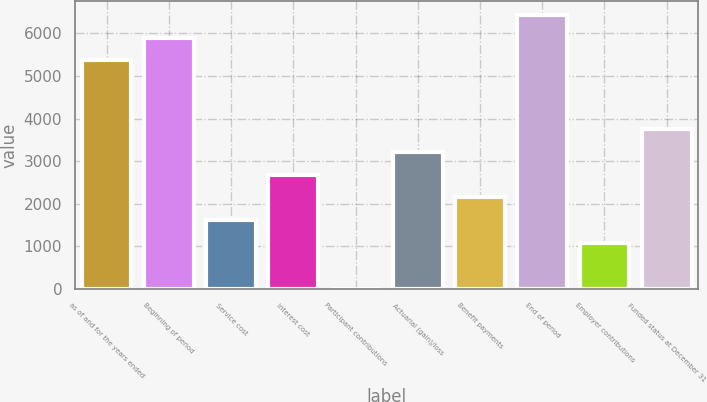Convert chart. <chart><loc_0><loc_0><loc_500><loc_500><bar_chart><fcel>as of and for the years ended<fcel>Beginning of period<fcel>Service cost<fcel>Interest cost<fcel>Participant contributions<fcel>Actuarial (gain)/loss<fcel>Benefit payments<fcel>End of period<fcel>Employer contributions<fcel>Funded status at December 31<nl><fcel>5364<fcel>5899.5<fcel>1615.5<fcel>2686.5<fcel>9<fcel>3222<fcel>2151<fcel>6435<fcel>1080<fcel>3757.5<nl></chart> 